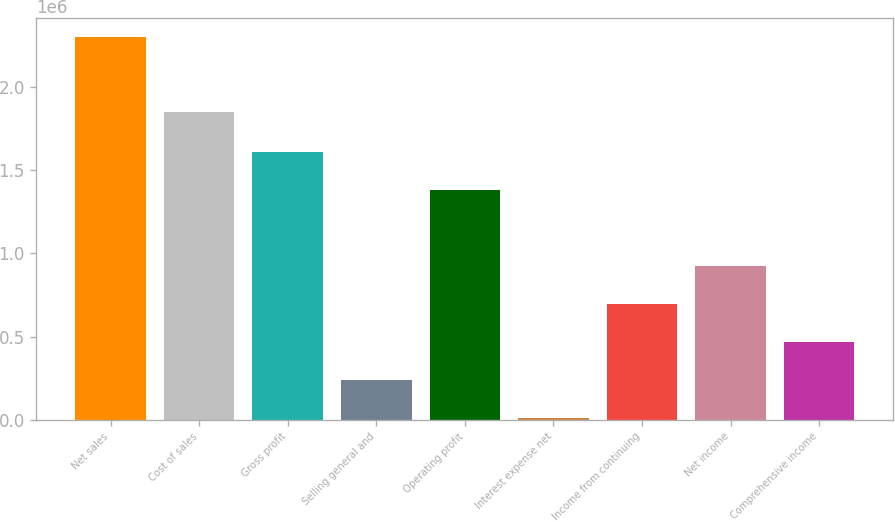Convert chart to OTSL. <chart><loc_0><loc_0><loc_500><loc_500><bar_chart><fcel>Net sales<fcel>Cost of sales<fcel>Gross profit<fcel>Selling general and<fcel>Operating profit<fcel>Interest expense net<fcel>Income from continuing<fcel>Net income<fcel>Comprehensive income<nl><fcel>2.30079e+06<fcel>1.85206e+06<fcel>1.61262e+06<fcel>236260<fcel>1.38322e+06<fcel>6867<fcel>695045<fcel>924438<fcel>465652<nl></chart> 